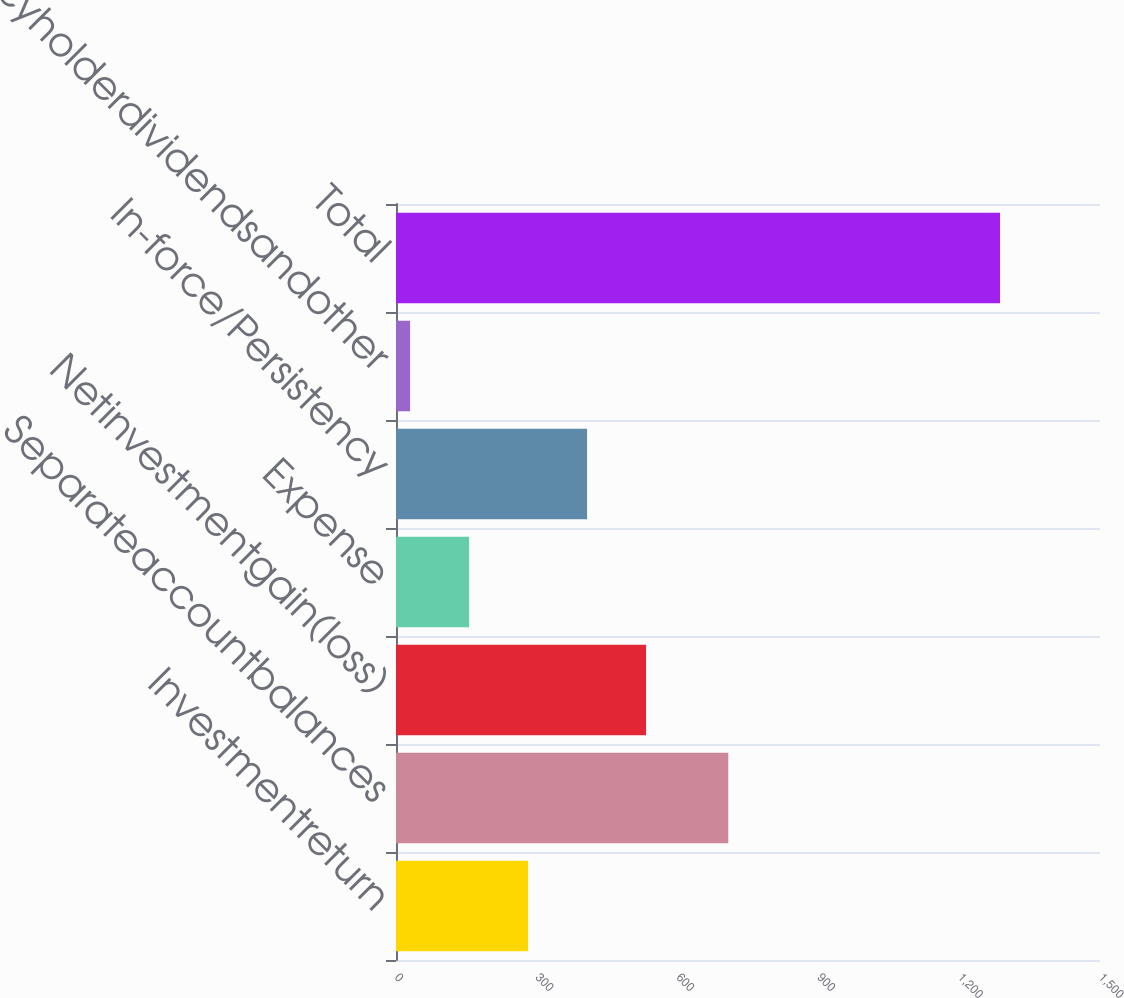Convert chart to OTSL. <chart><loc_0><loc_0><loc_500><loc_500><bar_chart><fcel>Investmentreturn<fcel>Separateaccountbalances<fcel>Netinvestmentgain(loss)<fcel>Expense<fcel>In-force/Persistency<fcel>Policyholderdividendsandother<fcel>Total<nl><fcel>281.4<fcel>708<fcel>532.8<fcel>155.7<fcel>407.1<fcel>30<fcel>1287<nl></chart> 